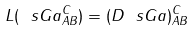<formula> <loc_0><loc_0><loc_500><loc_500>L ( \ s G a ^ { C } _ { A B } ) = ( D \ s G a ) ^ { C } _ { A B }</formula> 